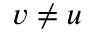Convert formula to latex. <formula><loc_0><loc_0><loc_500><loc_500>v \neq u</formula> 